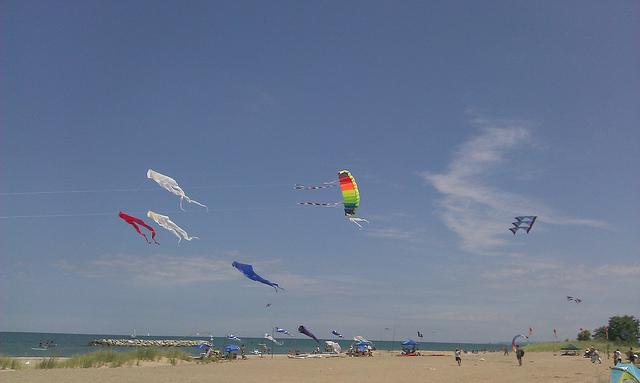Who uses the item in the sky the most?

Choices:
A) kids
B) police officers
C) army sergeants
D) old men kids 